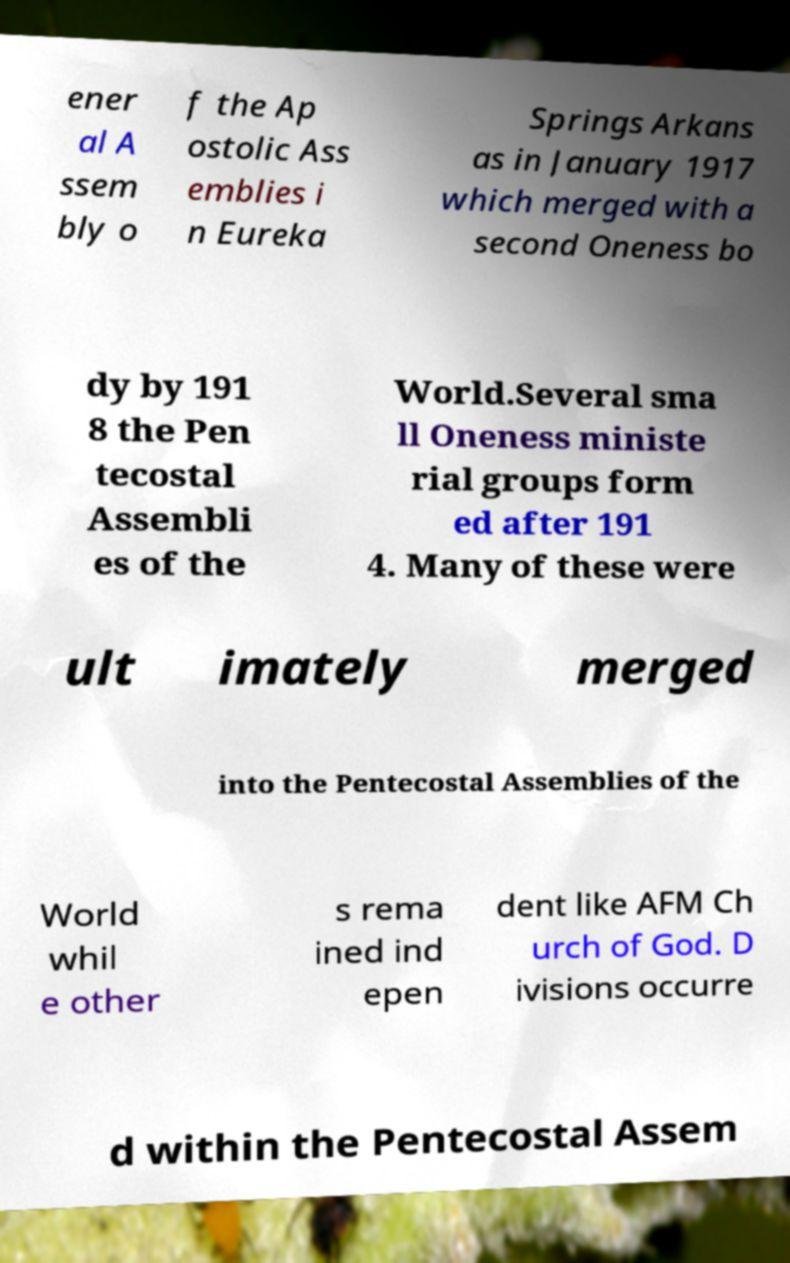What messages or text are displayed in this image? I need them in a readable, typed format. ener al A ssem bly o f the Ap ostolic Ass emblies i n Eureka Springs Arkans as in January 1917 which merged with a second Oneness bo dy by 191 8 the Pen tecostal Assembli es of the World.Several sma ll Oneness ministe rial groups form ed after 191 4. Many of these were ult imately merged into the Pentecostal Assemblies of the World whil e other s rema ined ind epen dent like AFM Ch urch of God. D ivisions occurre d within the Pentecostal Assem 